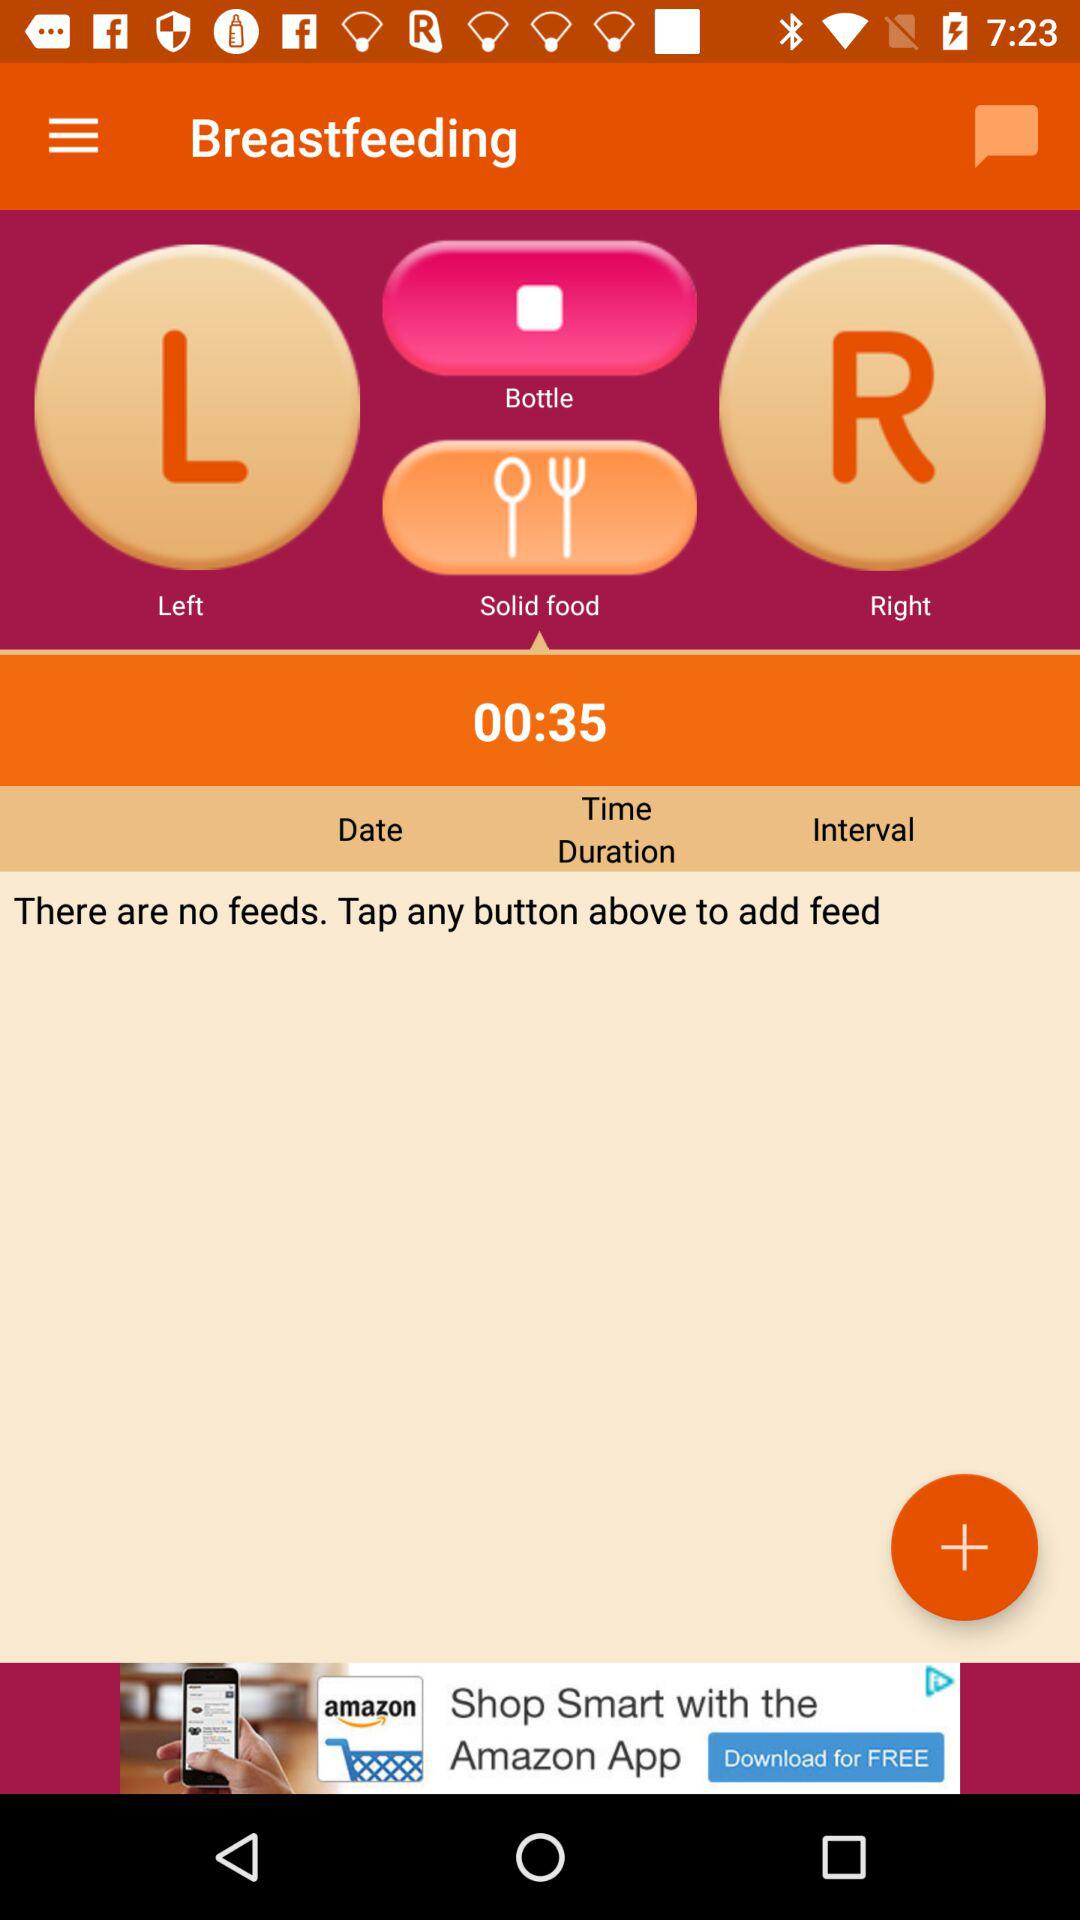What is the duration? The duration is 35 seconds. 